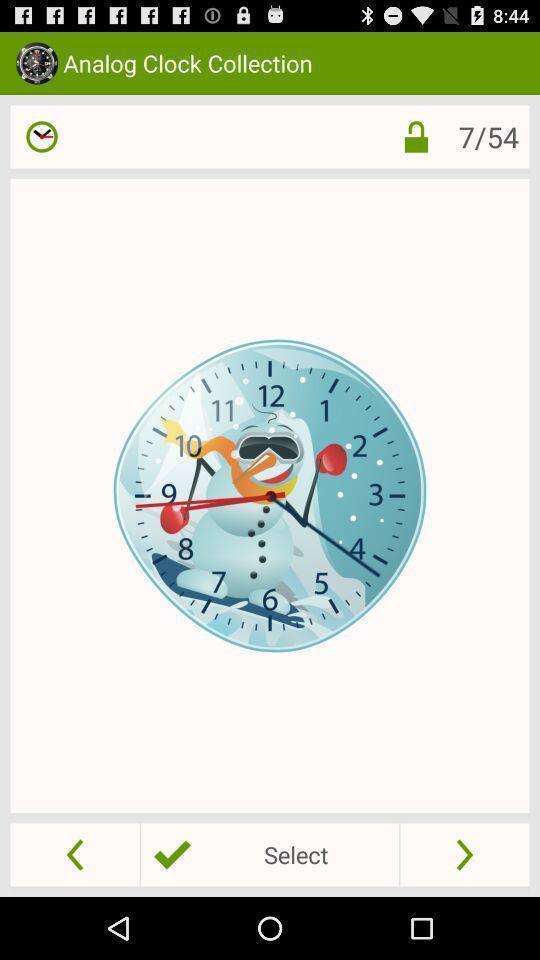What is the overall content of this screenshot? Page displaying with clock collection and few options. 